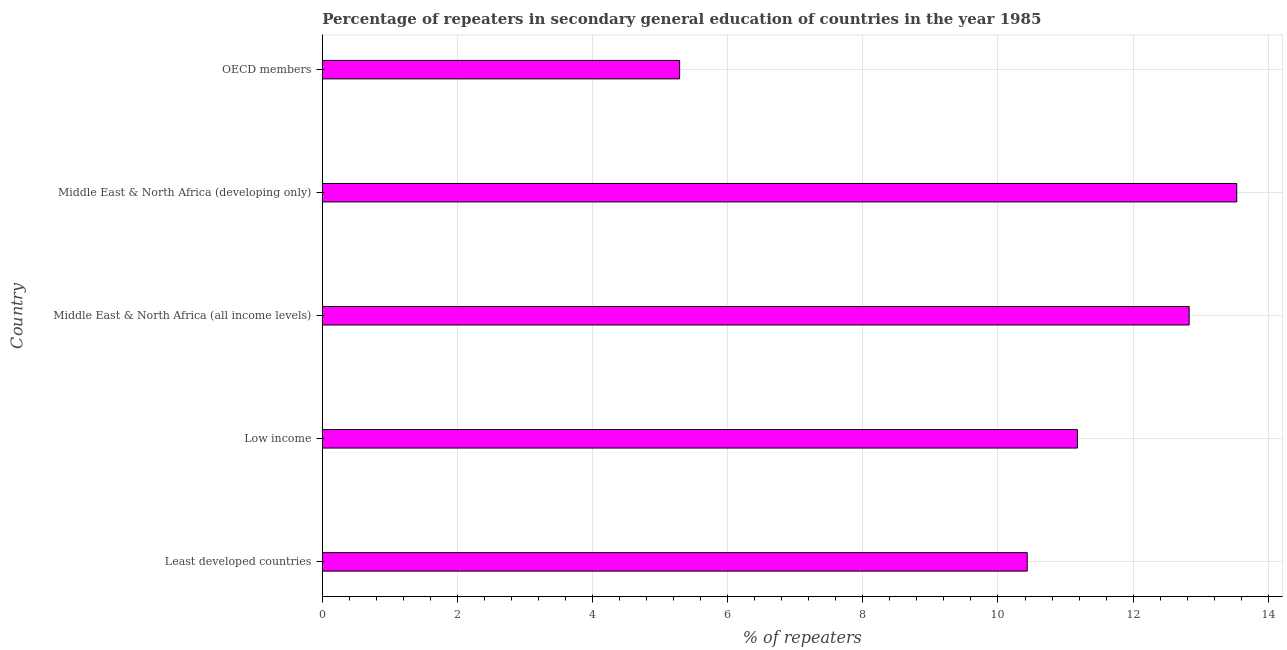Does the graph contain any zero values?
Offer a very short reply. No. Does the graph contain grids?
Ensure brevity in your answer.  Yes. What is the title of the graph?
Provide a succinct answer. Percentage of repeaters in secondary general education of countries in the year 1985. What is the label or title of the X-axis?
Your answer should be compact. % of repeaters. What is the label or title of the Y-axis?
Keep it short and to the point. Country. What is the percentage of repeaters in Middle East & North Africa (developing only)?
Make the answer very short. 13.53. Across all countries, what is the maximum percentage of repeaters?
Your answer should be very brief. 13.53. Across all countries, what is the minimum percentage of repeaters?
Provide a succinct answer. 5.29. In which country was the percentage of repeaters maximum?
Make the answer very short. Middle East & North Africa (developing only). What is the sum of the percentage of repeaters?
Provide a short and direct response. 53.26. What is the difference between the percentage of repeaters in Least developed countries and OECD members?
Give a very brief answer. 5.14. What is the average percentage of repeaters per country?
Make the answer very short. 10.65. What is the median percentage of repeaters?
Your answer should be very brief. 11.18. In how many countries, is the percentage of repeaters greater than 10.8 %?
Ensure brevity in your answer.  3. What is the ratio of the percentage of repeaters in Least developed countries to that in Middle East & North Africa (all income levels)?
Ensure brevity in your answer.  0.81. Is the percentage of repeaters in Least developed countries less than that in Middle East & North Africa (all income levels)?
Offer a terse response. Yes. What is the difference between the highest and the second highest percentage of repeaters?
Your answer should be compact. 0.7. What is the difference between the highest and the lowest percentage of repeaters?
Your answer should be compact. 8.25. In how many countries, is the percentage of repeaters greater than the average percentage of repeaters taken over all countries?
Keep it short and to the point. 3. How many bars are there?
Provide a succinct answer. 5. Are all the bars in the graph horizontal?
Provide a succinct answer. Yes. How many countries are there in the graph?
Your answer should be very brief. 5. Are the values on the major ticks of X-axis written in scientific E-notation?
Your response must be concise. No. What is the % of repeaters in Least developed countries?
Make the answer very short. 10.43. What is the % of repeaters in Low income?
Provide a succinct answer. 11.18. What is the % of repeaters in Middle East & North Africa (all income levels)?
Give a very brief answer. 12.83. What is the % of repeaters in Middle East & North Africa (developing only)?
Your response must be concise. 13.53. What is the % of repeaters of OECD members?
Ensure brevity in your answer.  5.29. What is the difference between the % of repeaters in Least developed countries and Low income?
Keep it short and to the point. -0.74. What is the difference between the % of repeaters in Least developed countries and Middle East & North Africa (all income levels)?
Your answer should be compact. -2.4. What is the difference between the % of repeaters in Least developed countries and Middle East & North Africa (developing only)?
Ensure brevity in your answer.  -3.1. What is the difference between the % of repeaters in Least developed countries and OECD members?
Your response must be concise. 5.14. What is the difference between the % of repeaters in Low income and Middle East & North Africa (all income levels)?
Your answer should be very brief. -1.65. What is the difference between the % of repeaters in Low income and Middle East & North Africa (developing only)?
Your answer should be compact. -2.36. What is the difference between the % of repeaters in Low income and OECD members?
Offer a very short reply. 5.89. What is the difference between the % of repeaters in Middle East & North Africa (all income levels) and Middle East & North Africa (developing only)?
Keep it short and to the point. -0.7. What is the difference between the % of repeaters in Middle East & North Africa (all income levels) and OECD members?
Make the answer very short. 7.54. What is the difference between the % of repeaters in Middle East & North Africa (developing only) and OECD members?
Make the answer very short. 8.25. What is the ratio of the % of repeaters in Least developed countries to that in Low income?
Your response must be concise. 0.93. What is the ratio of the % of repeaters in Least developed countries to that in Middle East & North Africa (all income levels)?
Provide a succinct answer. 0.81. What is the ratio of the % of repeaters in Least developed countries to that in Middle East & North Africa (developing only)?
Your response must be concise. 0.77. What is the ratio of the % of repeaters in Least developed countries to that in OECD members?
Provide a short and direct response. 1.97. What is the ratio of the % of repeaters in Low income to that in Middle East & North Africa (all income levels)?
Ensure brevity in your answer.  0.87. What is the ratio of the % of repeaters in Low income to that in Middle East & North Africa (developing only)?
Provide a succinct answer. 0.83. What is the ratio of the % of repeaters in Low income to that in OECD members?
Ensure brevity in your answer.  2.11. What is the ratio of the % of repeaters in Middle East & North Africa (all income levels) to that in Middle East & North Africa (developing only)?
Ensure brevity in your answer.  0.95. What is the ratio of the % of repeaters in Middle East & North Africa (all income levels) to that in OECD members?
Provide a short and direct response. 2.43. What is the ratio of the % of repeaters in Middle East & North Africa (developing only) to that in OECD members?
Provide a short and direct response. 2.56. 